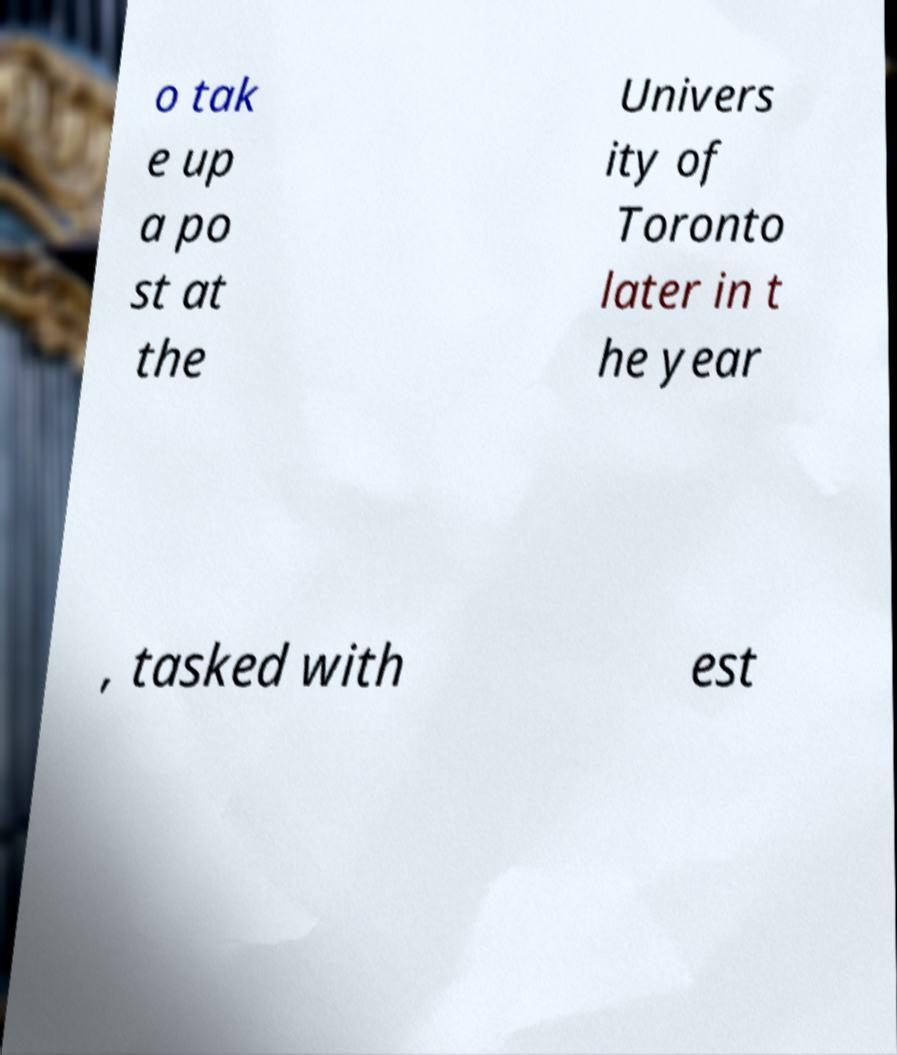What messages or text are displayed in this image? I need them in a readable, typed format. o tak e up a po st at the Univers ity of Toronto later in t he year , tasked with est 